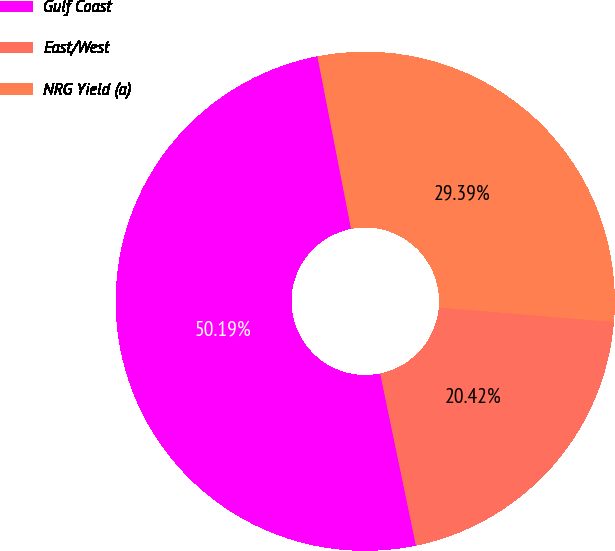<chart> <loc_0><loc_0><loc_500><loc_500><pie_chart><fcel>Gulf Coast<fcel>East/West<fcel>NRG Yield (a)<nl><fcel>50.2%<fcel>20.42%<fcel>29.39%<nl></chart> 